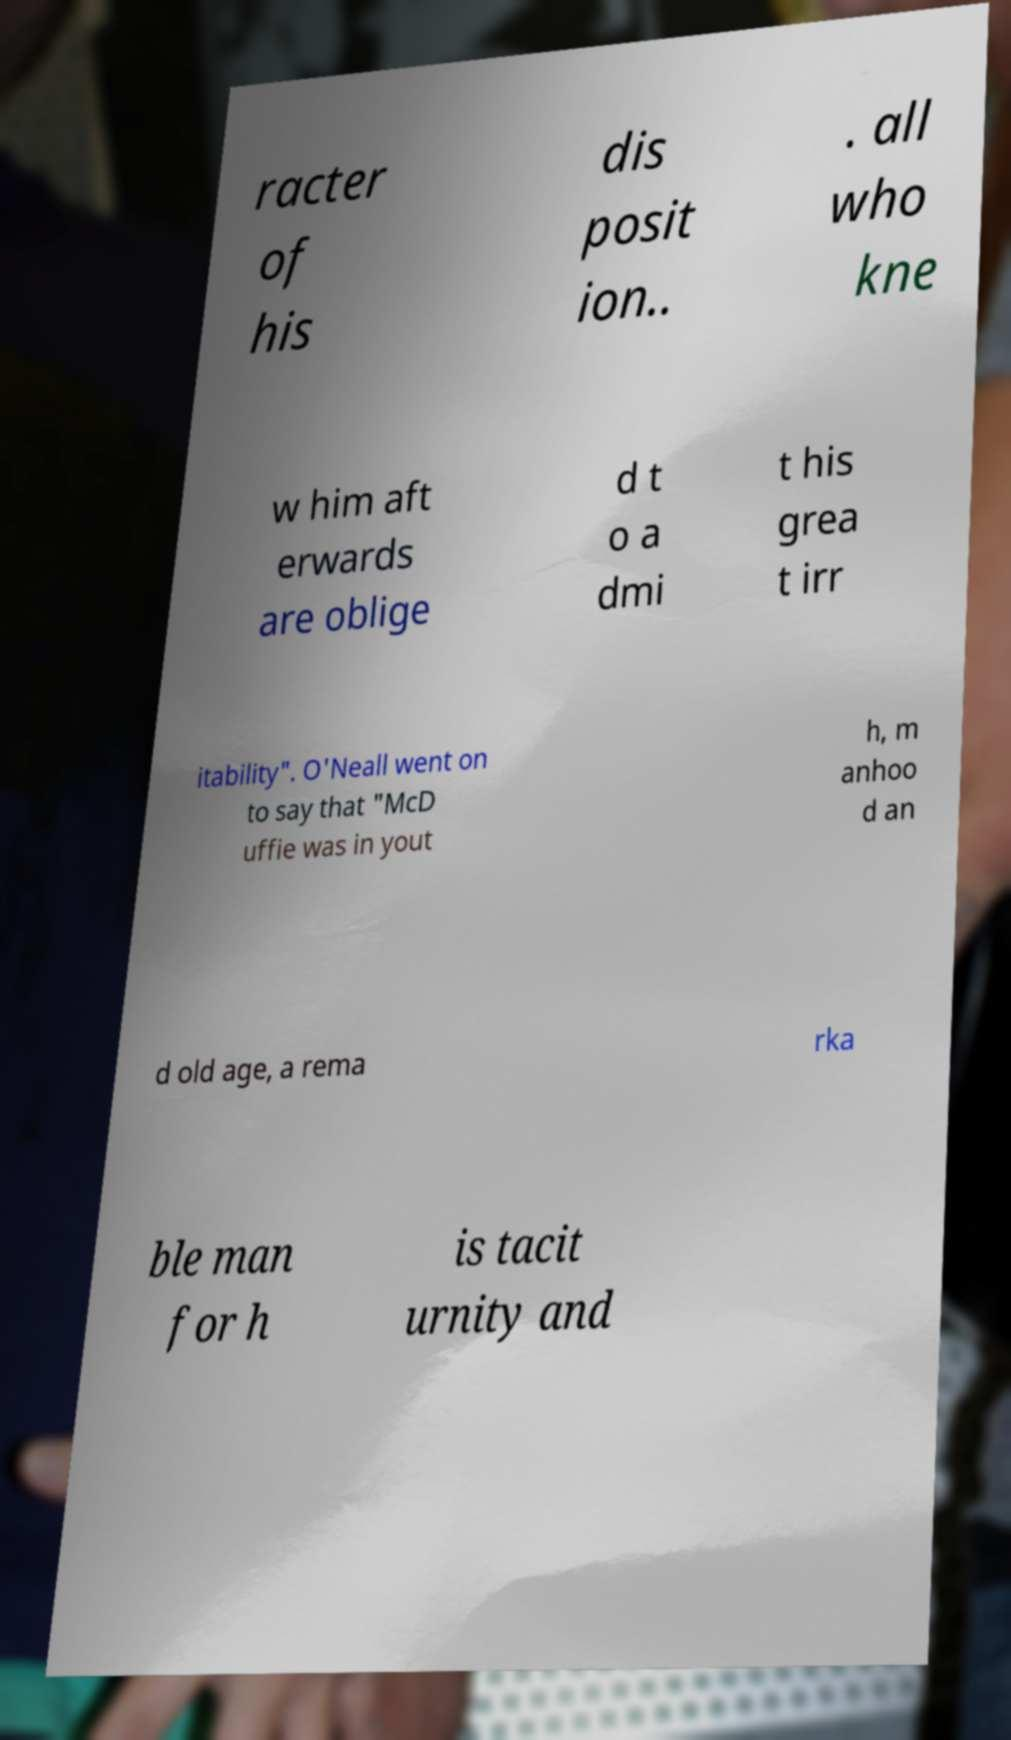I need the written content from this picture converted into text. Can you do that? racter of his dis posit ion.. . all who kne w him aft erwards are oblige d t o a dmi t his grea t irr itability". O'Neall went on to say that "McD uffie was in yout h, m anhoo d an d old age, a rema rka ble man for h is tacit urnity and 